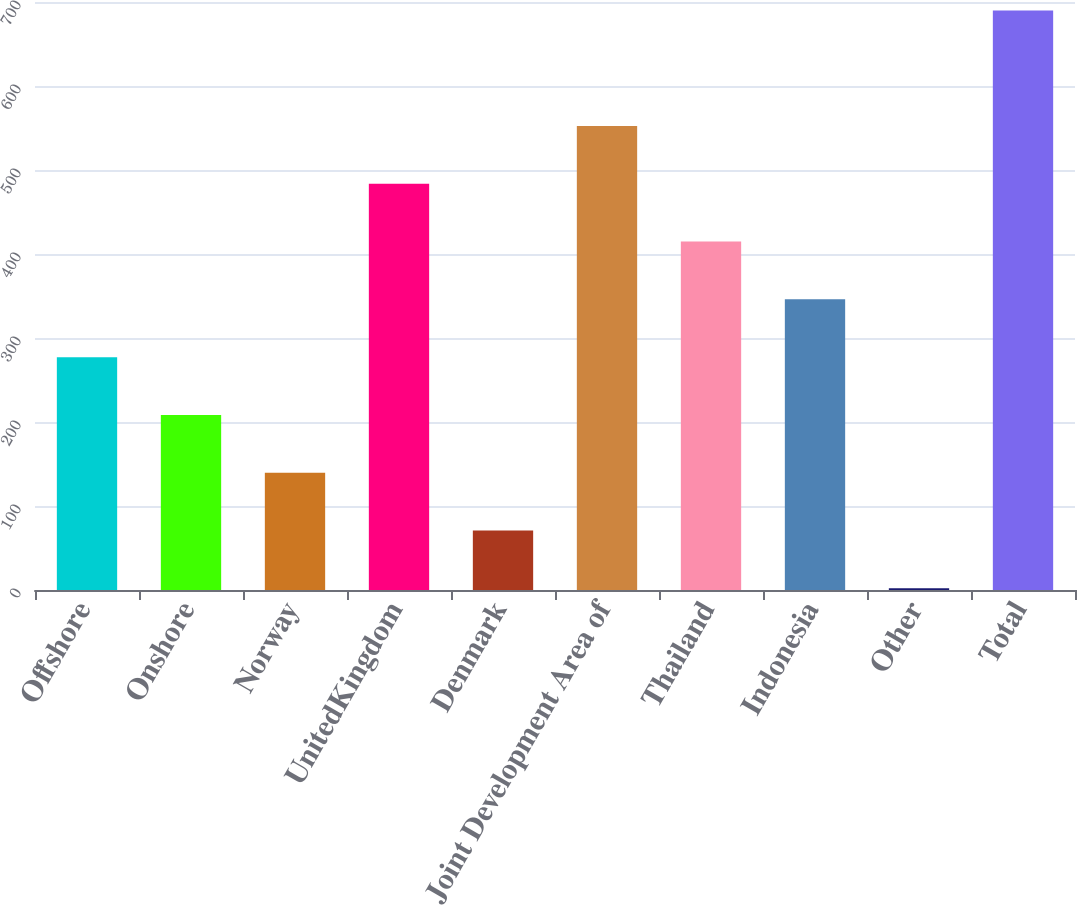Convert chart to OTSL. <chart><loc_0><loc_0><loc_500><loc_500><bar_chart><fcel>Offshore<fcel>Onshore<fcel>Norway<fcel>UnitedKingdom<fcel>Denmark<fcel>Joint Development Area of<fcel>Thailand<fcel>Indonesia<fcel>Other<fcel>Total<nl><fcel>277.2<fcel>208.4<fcel>139.6<fcel>483.6<fcel>70.8<fcel>552.4<fcel>414.8<fcel>346<fcel>2<fcel>690<nl></chart> 